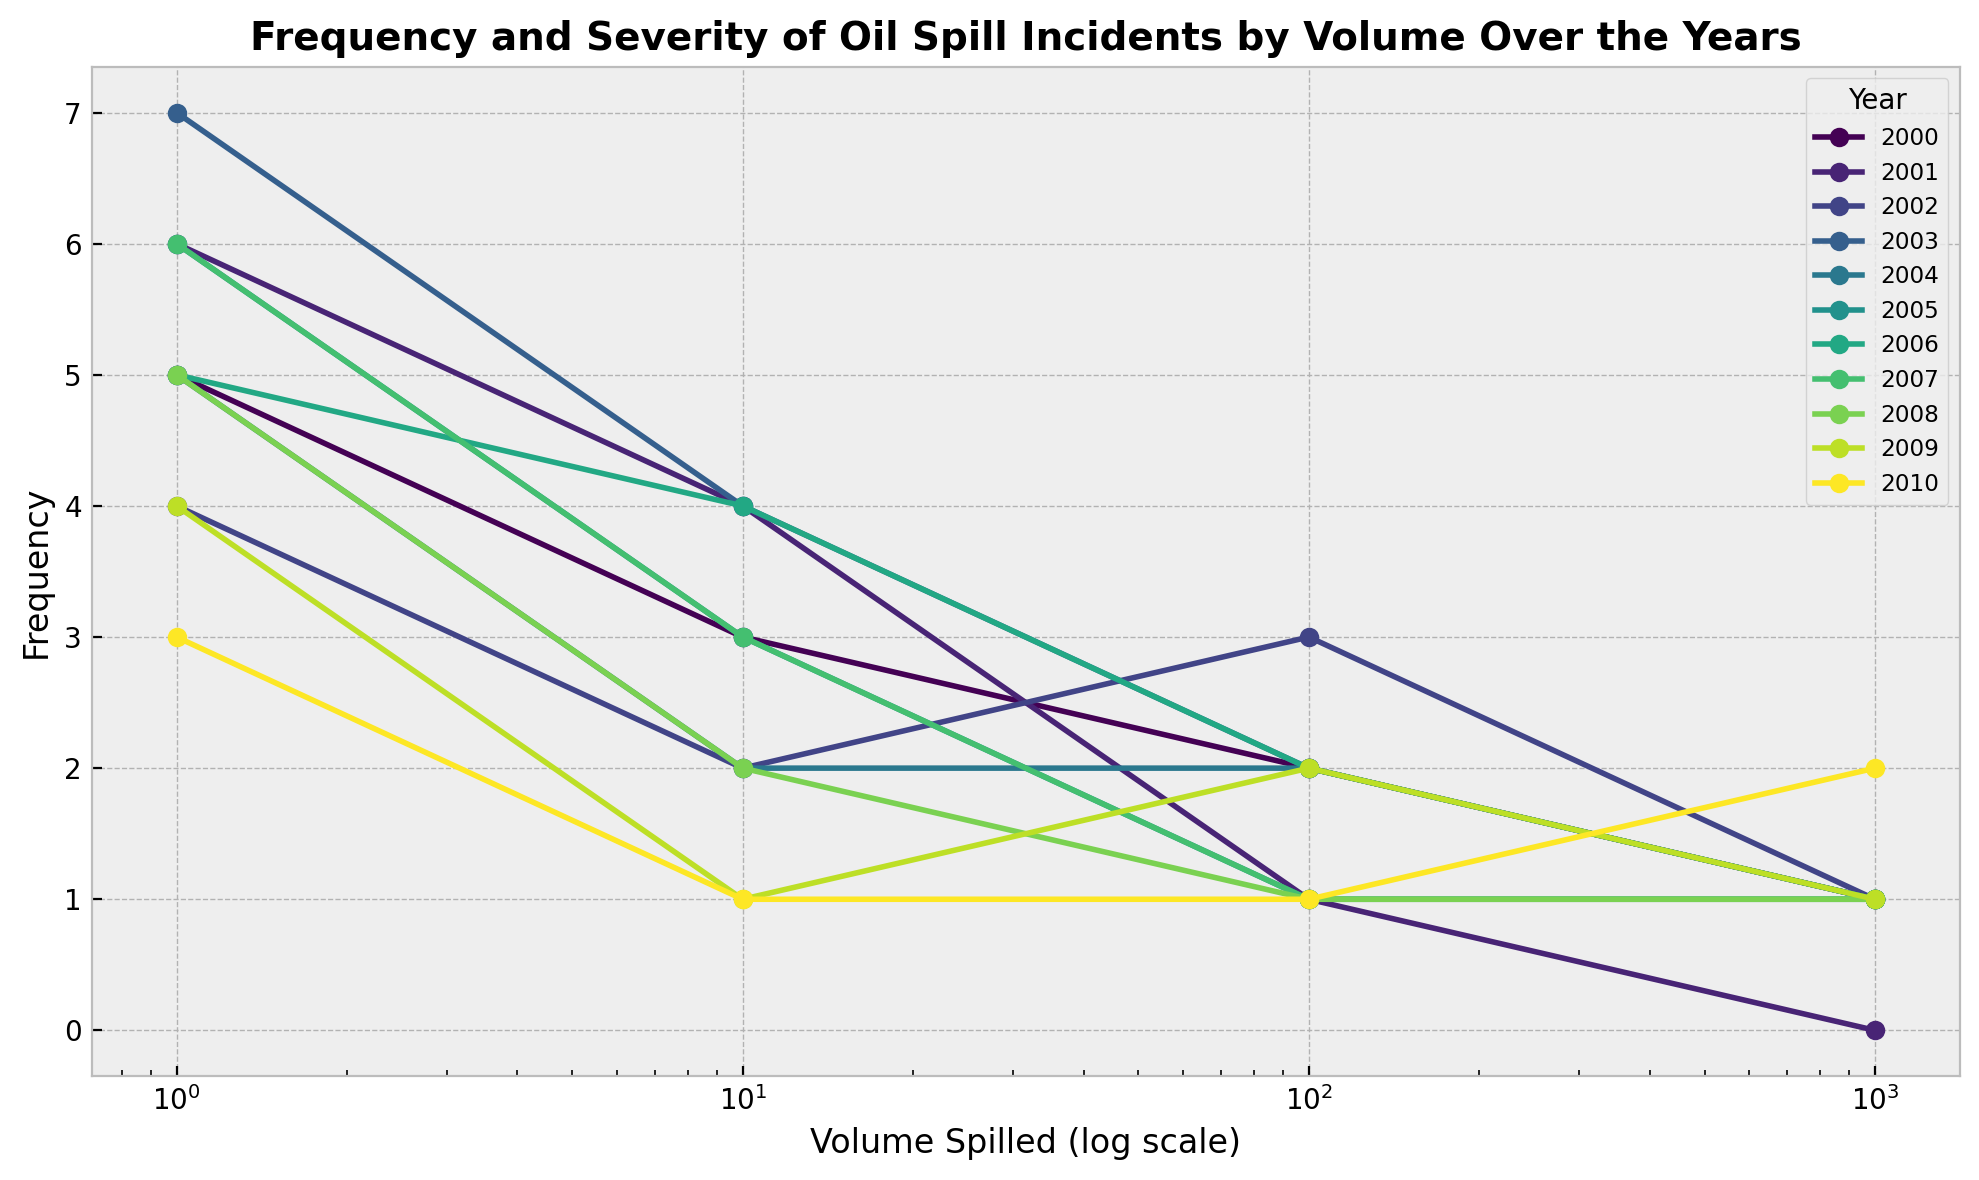How does the frequency of oil spills with a volume of 1,000 barrels in 2000 compare to 2001? To compare the frequencies, we look at the data points for the volume of 1,000 barrels for both years. In 2000, the frequency is 1, and in 2001, the frequency is 0. Therefore, there were more spills of this volume in 2000 compared to 2001.
Answer: 2000 had more frequency Among the volumes 1, 10, 100, and 1,000 barrels, which one had the highest frequency in any given year? To determine this, we need to check the maximum frequency for each volume across all years from the chart. Upon inspection, the volume of 1 barrel has the highest frequency in the year 2003 with a frequency of 7.
Answer: 1 barrel in 2003 What is the trend of oil spills frequency for the volume of 10 barrels from 2000 to 2010? Observing the trend for the volume of 10 barrels: in 2000 the frequency is 3, 2001 is 4, 2002 is 2, 2003 is 4, 2004 is 2, 2005 is 3, 2006 is 4, 2007 is 3, 2008 is 2, 2009 is 1, and 2010 is 1. The frequency generally decreases over this period.
Answer: Decreasing Which year experienced the highest overall frequency of oil spills regardless of volume? Summing the frequencies for each year and comparing: 2000 (5+3+2+1=11), 2001 (6+4+1+0=11), 2002 (4+2+3+1=10), 2003 (7+4+2+1=14), and so on. The year 2003 has the highest total frequency of 14.
Answer: 2003 How does the frequency of oil spills with volumes of 10 and 100 barrels in 2008 compare? Observing the data for the year 2008: the frequency for 10 barrels is 2 and for 100 barrels is 1. Thus, there were more spills of 10 barrels compared to 100 barrels in 2008.
Answer: 10 barrels more frequent Which year had no oil spills of 1,000 barrels in volume? According to the data points, 2001 is the only year with a frequency of 0 for 1,000 barrels.
Answer: 2001 Based on visual inspection, does any volume show a decreasing trend in frequency over the years? Observing the trend lines for different volumes: the volume of 10 barrels shows a visually decreasing trend in frequency from 2000 to 2010.
Answer: 10 barrels In which year did the smallest volume of oil spills (1 barrel) occur most frequently, and what was the frequency? Checking the data for 1 barrel by year, the year with the highest frequency is 2003 with a frequency of 7.
Answer: 2003, frequency 7 What is the comparison in frequency between volumes of 1 and 100 barrels in the year 2005? Observing the data for 2005: the frequency for 1 barrel is 6 and for 100 barrels is 1. Therefore, spills of 1 barrel occurred more frequently than spills of 100 barrels in 2005.
Answer: 1 barrel more frequent 